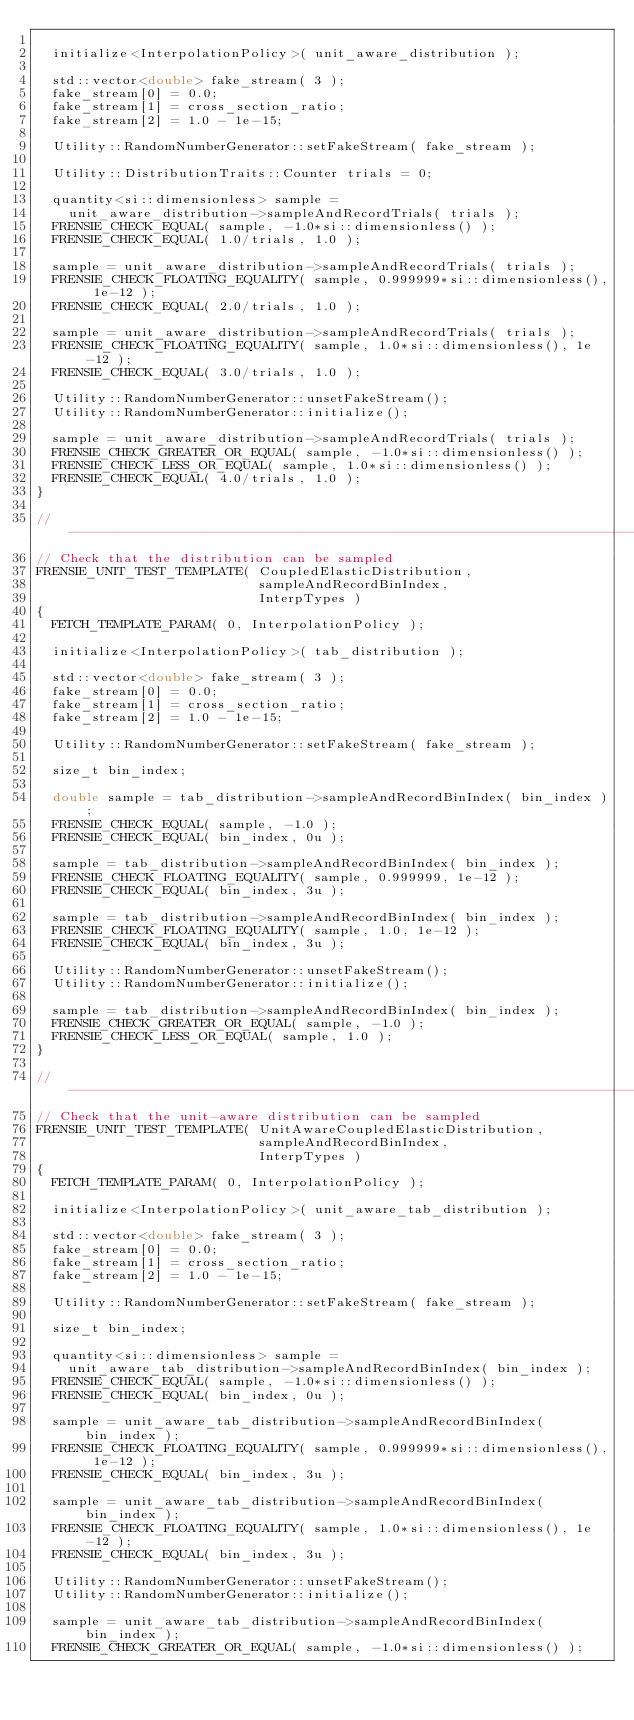Convert code to text. <code><loc_0><loc_0><loc_500><loc_500><_C++_>
  initialize<InterpolationPolicy>( unit_aware_distribution );

  std::vector<double> fake_stream( 3 );
  fake_stream[0] = 0.0;
  fake_stream[1] = cross_section_ratio;
  fake_stream[2] = 1.0 - 1e-15;

  Utility::RandomNumberGenerator::setFakeStream( fake_stream );

  Utility::DistributionTraits::Counter trials = 0;

  quantity<si::dimensionless> sample =
    unit_aware_distribution->sampleAndRecordTrials( trials );
  FRENSIE_CHECK_EQUAL( sample, -1.0*si::dimensionless() );
  FRENSIE_CHECK_EQUAL( 1.0/trials, 1.0 );

  sample = unit_aware_distribution->sampleAndRecordTrials( trials );
  FRENSIE_CHECK_FLOATING_EQUALITY( sample, 0.999999*si::dimensionless(), 1e-12 );
  FRENSIE_CHECK_EQUAL( 2.0/trials, 1.0 );

  sample = unit_aware_distribution->sampleAndRecordTrials( trials );
  FRENSIE_CHECK_FLOATING_EQUALITY( sample, 1.0*si::dimensionless(), 1e-12 );
  FRENSIE_CHECK_EQUAL( 3.0/trials, 1.0 );

  Utility::RandomNumberGenerator::unsetFakeStream();
  Utility::RandomNumberGenerator::initialize();

  sample = unit_aware_distribution->sampleAndRecordTrials( trials );
  FRENSIE_CHECK_GREATER_OR_EQUAL( sample, -1.0*si::dimensionless() );
  FRENSIE_CHECK_LESS_OR_EQUAL( sample, 1.0*si::dimensionless() );
  FRENSIE_CHECK_EQUAL( 4.0/trials, 1.0 );
}

//---------------------------------------------------------------------------//
// Check that the distribution can be sampled
FRENSIE_UNIT_TEST_TEMPLATE( CoupledElasticDistribution,
                            sampleAndRecordBinIndex,
                            InterpTypes )
{
  FETCH_TEMPLATE_PARAM( 0, InterpolationPolicy );

  initialize<InterpolationPolicy>( tab_distribution );

  std::vector<double> fake_stream( 3 );
  fake_stream[0] = 0.0;
  fake_stream[1] = cross_section_ratio;
  fake_stream[2] = 1.0 - 1e-15;

  Utility::RandomNumberGenerator::setFakeStream( fake_stream );

  size_t bin_index;

  double sample = tab_distribution->sampleAndRecordBinIndex( bin_index );
  FRENSIE_CHECK_EQUAL( sample, -1.0 );
  FRENSIE_CHECK_EQUAL( bin_index, 0u );

  sample = tab_distribution->sampleAndRecordBinIndex( bin_index );
  FRENSIE_CHECK_FLOATING_EQUALITY( sample, 0.999999, 1e-12 );
  FRENSIE_CHECK_EQUAL( bin_index, 3u );

  sample = tab_distribution->sampleAndRecordBinIndex( bin_index );
  FRENSIE_CHECK_FLOATING_EQUALITY( sample, 1.0, 1e-12 );
  FRENSIE_CHECK_EQUAL( bin_index, 3u );

  Utility::RandomNumberGenerator::unsetFakeStream();
  Utility::RandomNumberGenerator::initialize();

  sample = tab_distribution->sampleAndRecordBinIndex( bin_index );
  FRENSIE_CHECK_GREATER_OR_EQUAL( sample, -1.0 );
  FRENSIE_CHECK_LESS_OR_EQUAL( sample, 1.0 );
}

//---------------------------------------------------------------------------//
// Check that the unit-aware distribution can be sampled
FRENSIE_UNIT_TEST_TEMPLATE( UnitAwareCoupledElasticDistribution,
                            sampleAndRecordBinIndex,
                            InterpTypes )
{
  FETCH_TEMPLATE_PARAM( 0, InterpolationPolicy );

  initialize<InterpolationPolicy>( unit_aware_tab_distribution );

  std::vector<double> fake_stream( 3 );
  fake_stream[0] = 0.0;
  fake_stream[1] = cross_section_ratio;
  fake_stream[2] = 1.0 - 1e-15;

  Utility::RandomNumberGenerator::setFakeStream( fake_stream );

  size_t bin_index;

  quantity<si::dimensionless> sample =
    unit_aware_tab_distribution->sampleAndRecordBinIndex( bin_index );
  FRENSIE_CHECK_EQUAL( sample, -1.0*si::dimensionless() );
  FRENSIE_CHECK_EQUAL( bin_index, 0u );

  sample = unit_aware_tab_distribution->sampleAndRecordBinIndex( bin_index );
  FRENSIE_CHECK_FLOATING_EQUALITY( sample, 0.999999*si::dimensionless(), 1e-12 );
  FRENSIE_CHECK_EQUAL( bin_index, 3u );

  sample = unit_aware_tab_distribution->sampleAndRecordBinIndex( bin_index );
  FRENSIE_CHECK_FLOATING_EQUALITY( sample, 1.0*si::dimensionless(), 1e-12 );
  FRENSIE_CHECK_EQUAL( bin_index, 3u );

  Utility::RandomNumberGenerator::unsetFakeStream();
  Utility::RandomNumberGenerator::initialize();

  sample = unit_aware_tab_distribution->sampleAndRecordBinIndex( bin_index );
  FRENSIE_CHECK_GREATER_OR_EQUAL( sample, -1.0*si::dimensionless() );</code> 